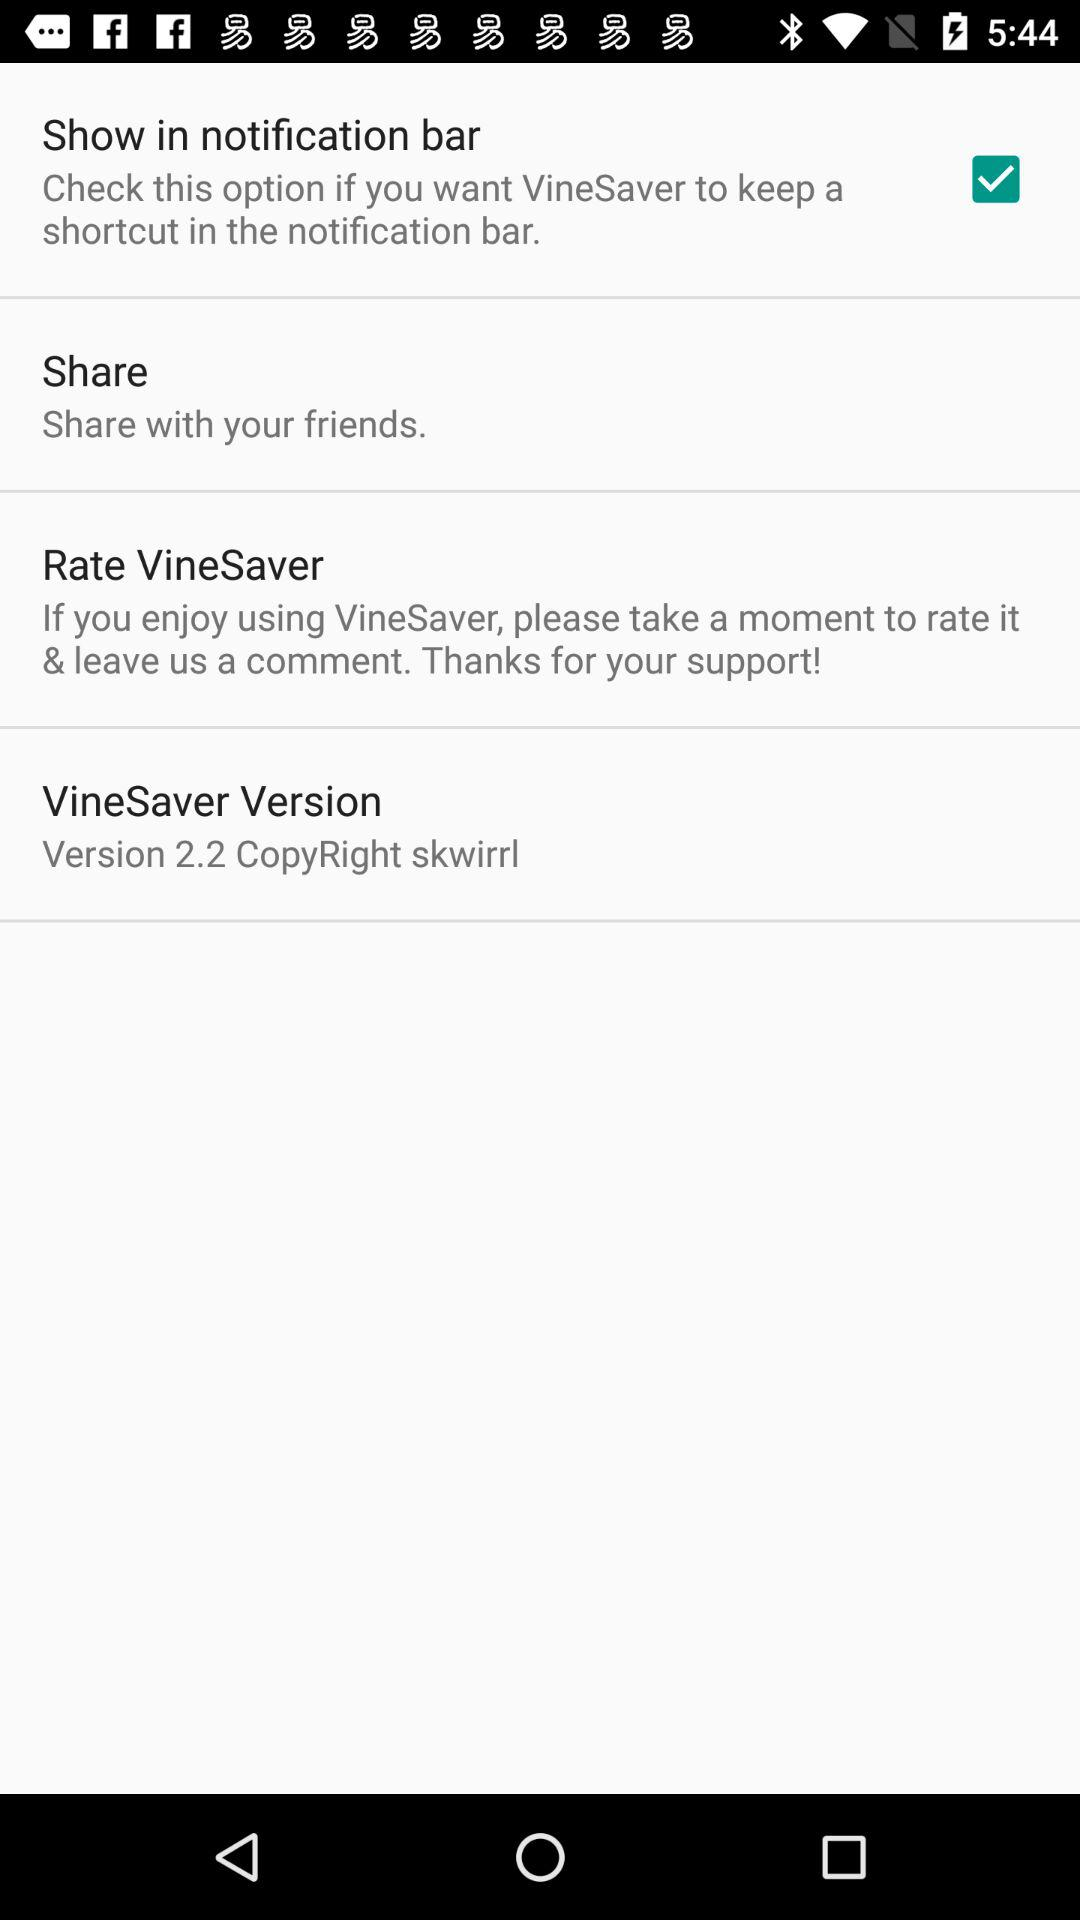What is the version of the application? The version of the application is 2.2. 